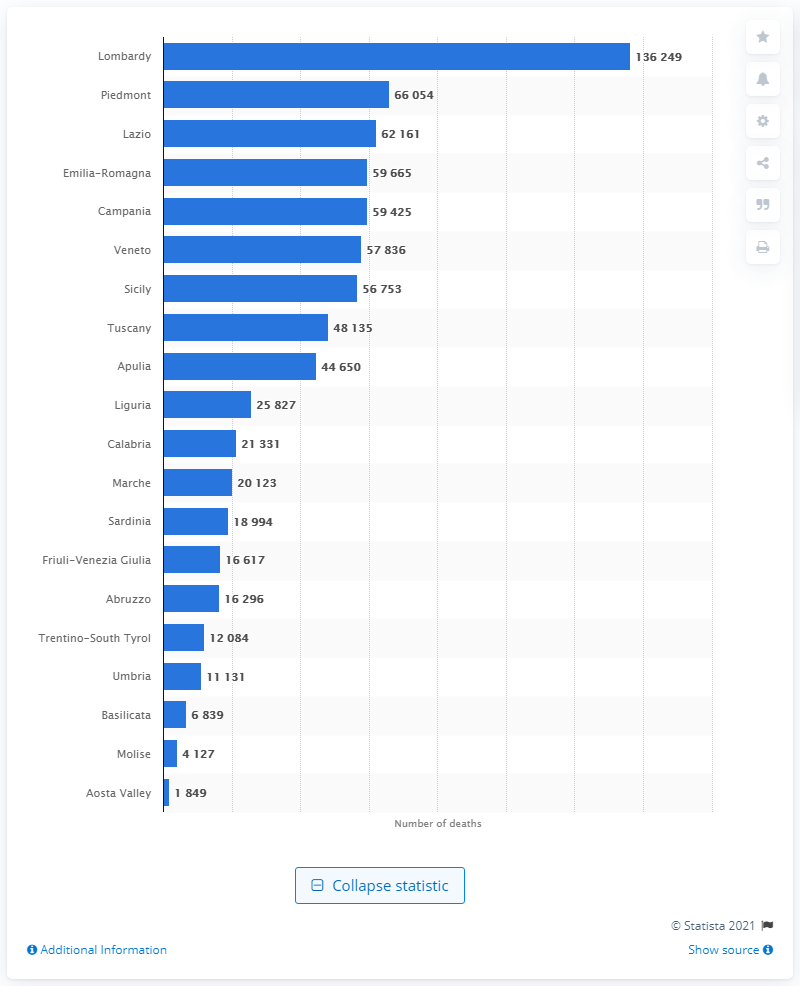List a handful of essential elements in this visual. In 2020, a total of 136,249 people lost their lives in the region of Lombardy. Lombardy has the highest population among all regions. In the year 2020, a total of 66,054 people died in the region of Lazio. 